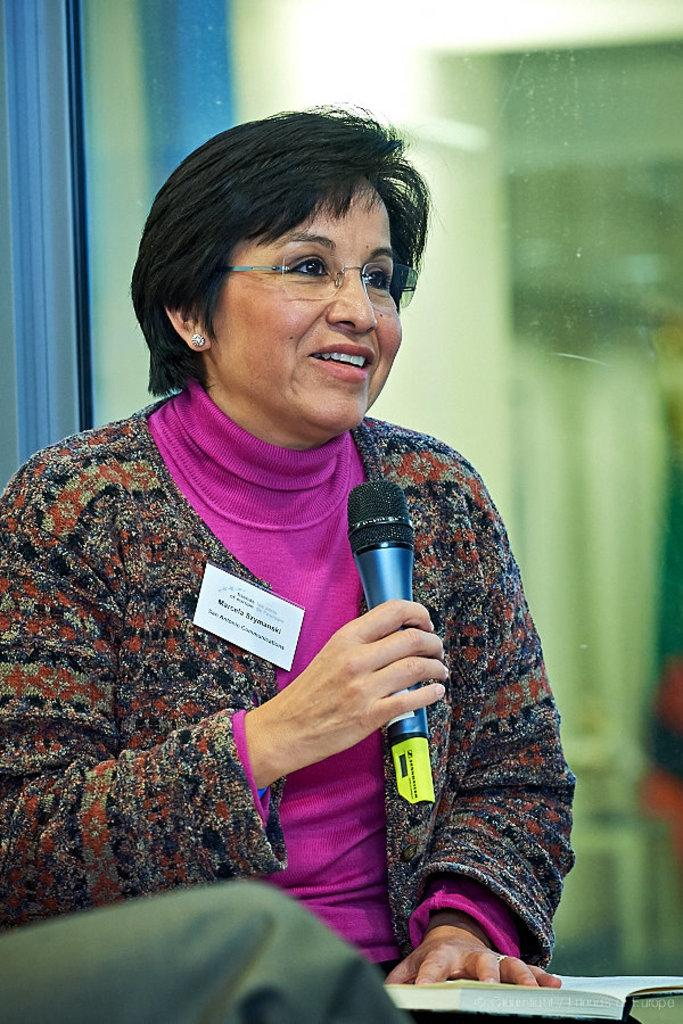What is the main subject of the image? There is a woman in the image. What is the woman holding in the image? The woman is holding a microphone. What is the woman's posture in the image? The woman is sitting. What is the woman's facial expression in the image? The woman is laughing. What can be seen in the background of the image? There is a glass door in the background of the image. What direction are the woman's toes pointing in the image? The image does not show the woman's toes, so it is not possible to determine their direction. 